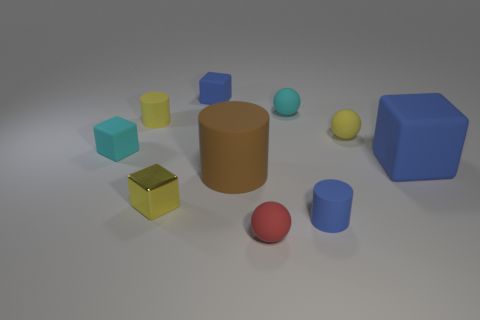Subtract all small matte cylinders. How many cylinders are left? 1 Subtract all cyan cylinders. How many blue blocks are left? 2 Subtract all blue cylinders. How many cylinders are left? 2 Subtract all cubes. How many objects are left? 6 Subtract 2 balls. How many balls are left? 1 Add 2 tiny blue matte cubes. How many tiny blue matte cubes are left? 3 Add 4 small cubes. How many small cubes exist? 7 Subtract 0 red blocks. How many objects are left? 10 Subtract all cyan cubes. Subtract all gray cylinders. How many cubes are left? 3 Subtract all small yellow rubber balls. Subtract all small yellow cylinders. How many objects are left? 8 